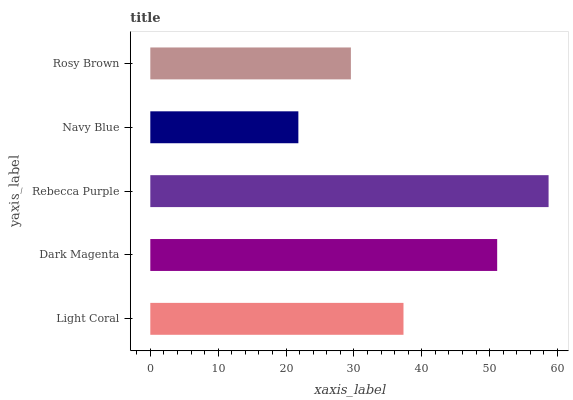Is Navy Blue the minimum?
Answer yes or no. Yes. Is Rebecca Purple the maximum?
Answer yes or no. Yes. Is Dark Magenta the minimum?
Answer yes or no. No. Is Dark Magenta the maximum?
Answer yes or no. No. Is Dark Magenta greater than Light Coral?
Answer yes or no. Yes. Is Light Coral less than Dark Magenta?
Answer yes or no. Yes. Is Light Coral greater than Dark Magenta?
Answer yes or no. No. Is Dark Magenta less than Light Coral?
Answer yes or no. No. Is Light Coral the high median?
Answer yes or no. Yes. Is Light Coral the low median?
Answer yes or no. Yes. Is Rebecca Purple the high median?
Answer yes or no. No. Is Rebecca Purple the low median?
Answer yes or no. No. 